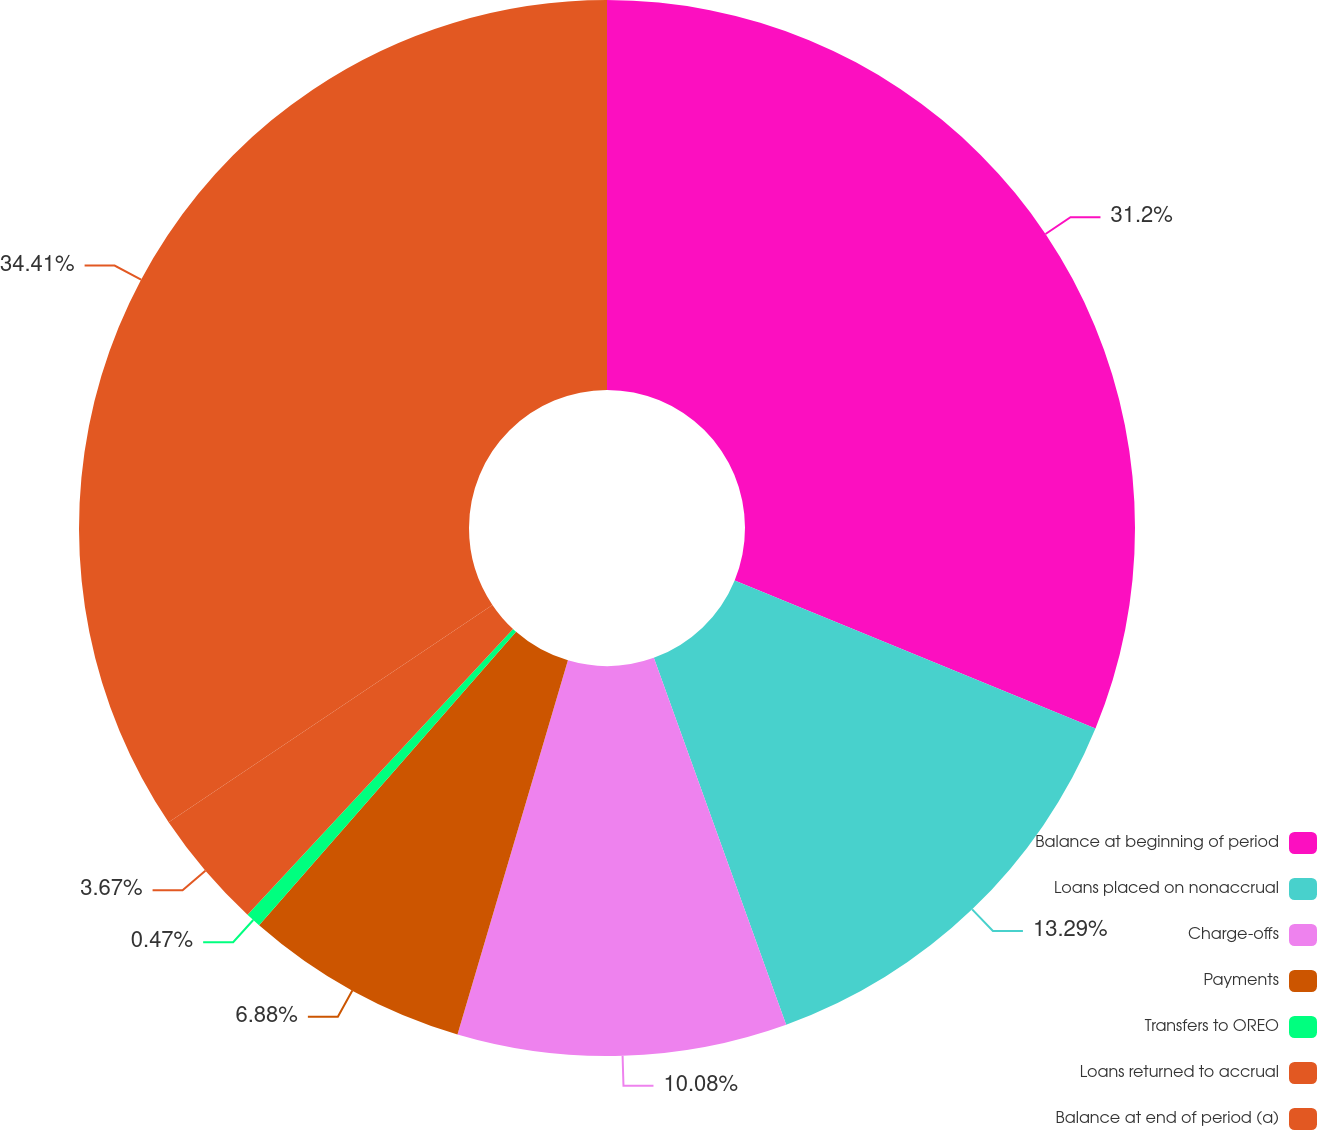Convert chart. <chart><loc_0><loc_0><loc_500><loc_500><pie_chart><fcel>Balance at beginning of period<fcel>Loans placed on nonaccrual<fcel>Charge-offs<fcel>Payments<fcel>Transfers to OREO<fcel>Loans returned to accrual<fcel>Balance at end of period (a)<nl><fcel>31.2%<fcel>13.29%<fcel>10.08%<fcel>6.88%<fcel>0.47%<fcel>3.67%<fcel>34.41%<nl></chart> 